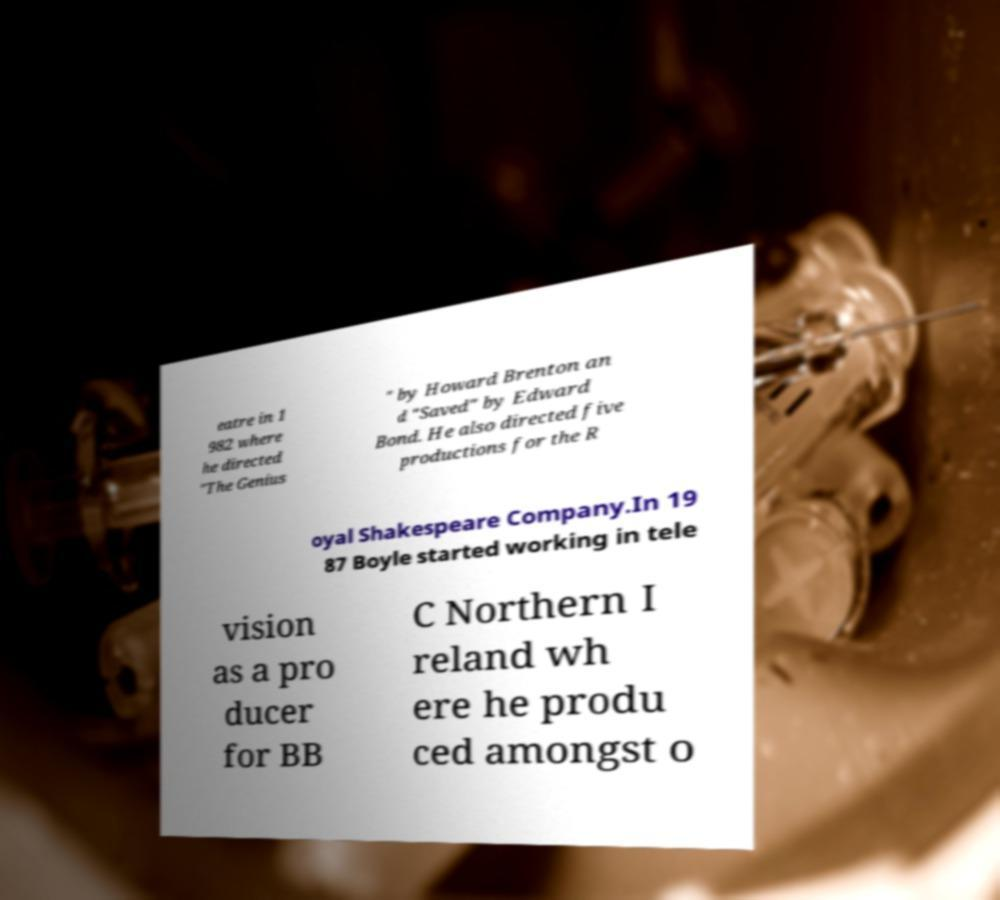Could you extract and type out the text from this image? eatre in 1 982 where he directed "The Genius " by Howard Brenton an d "Saved" by Edward Bond. He also directed five productions for the R oyal Shakespeare Company.In 19 87 Boyle started working in tele vision as a pro ducer for BB C Northern I reland wh ere he produ ced amongst o 